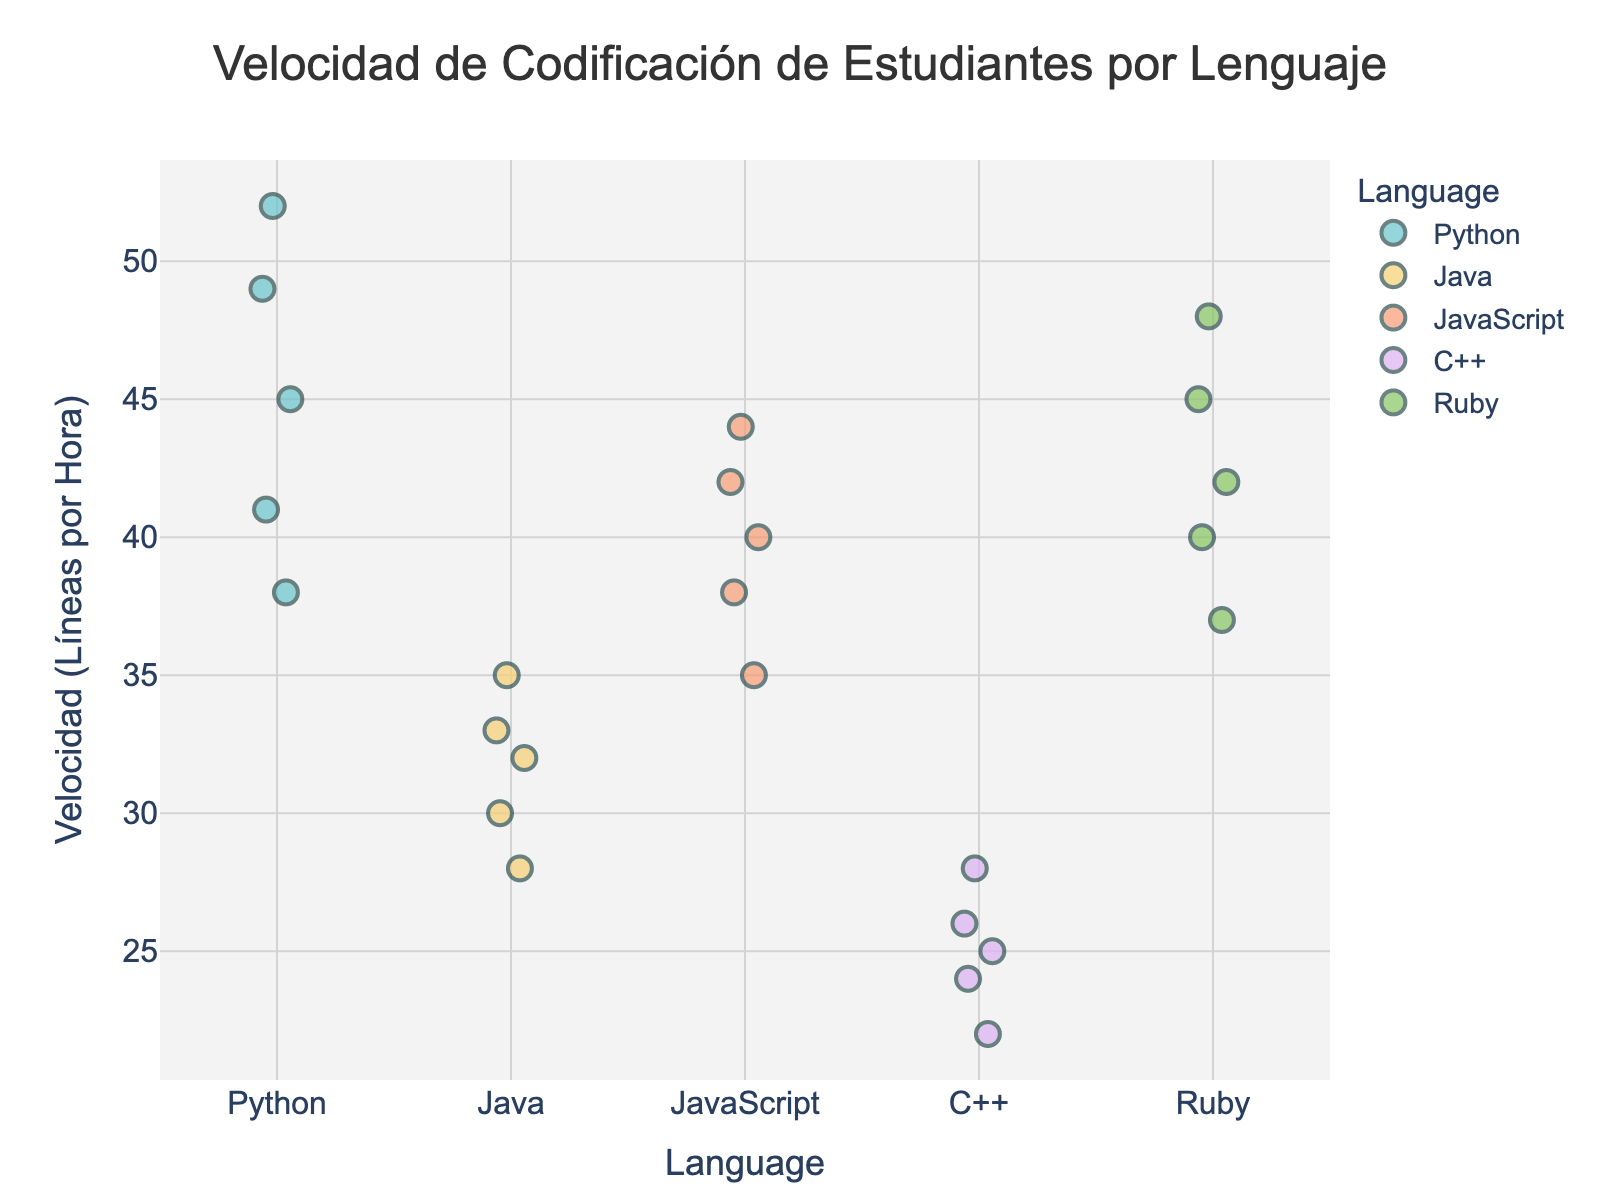What is the maximum coding speed for Python? Locate the highest data point for Python in the strip plot. This represents the maximum speed.
Answer: 52 How many data points are there for the JavaScript language? Count the number of markers associated with JavaScript on the plot.
Answer: 5 Which programming language shows the lowest coding speed? Identify the lowest data marker across all languages in the strip plot, which appears in the C++ group.
Answer: C++ What is the average coding speed for the Ruby language? Sum the coding speeds for Ruby (42, 37, 48, 40, 45) and divide by the number of data points. (42 + 37 + 48 + 40 + 45) / 5 = 212 / 5
Answer: 42.4 Which language has the most dispersed range of coding speeds? Observe the spread of data points for each language in the strip plot and identify which has the widest range.
Answer: Python What is the difference in maximum coding speed between Python and Java? Locate the maximum speeds for Python (52) and Java (35) from the plot and subtract. 52 - 35
Answer: 17 Is the median coding speed for JavaScript higher than that for C++? Find the median value for both JavaScript (40) and C++ (25) from their sorted data points and compare.
Answer: Yes For which language is the coding speed most clustered around the same value? Check for clusters of overlapping data points in each language. Ruby has tightly clustered markers around the mid-40s.
Answer: Ruby 